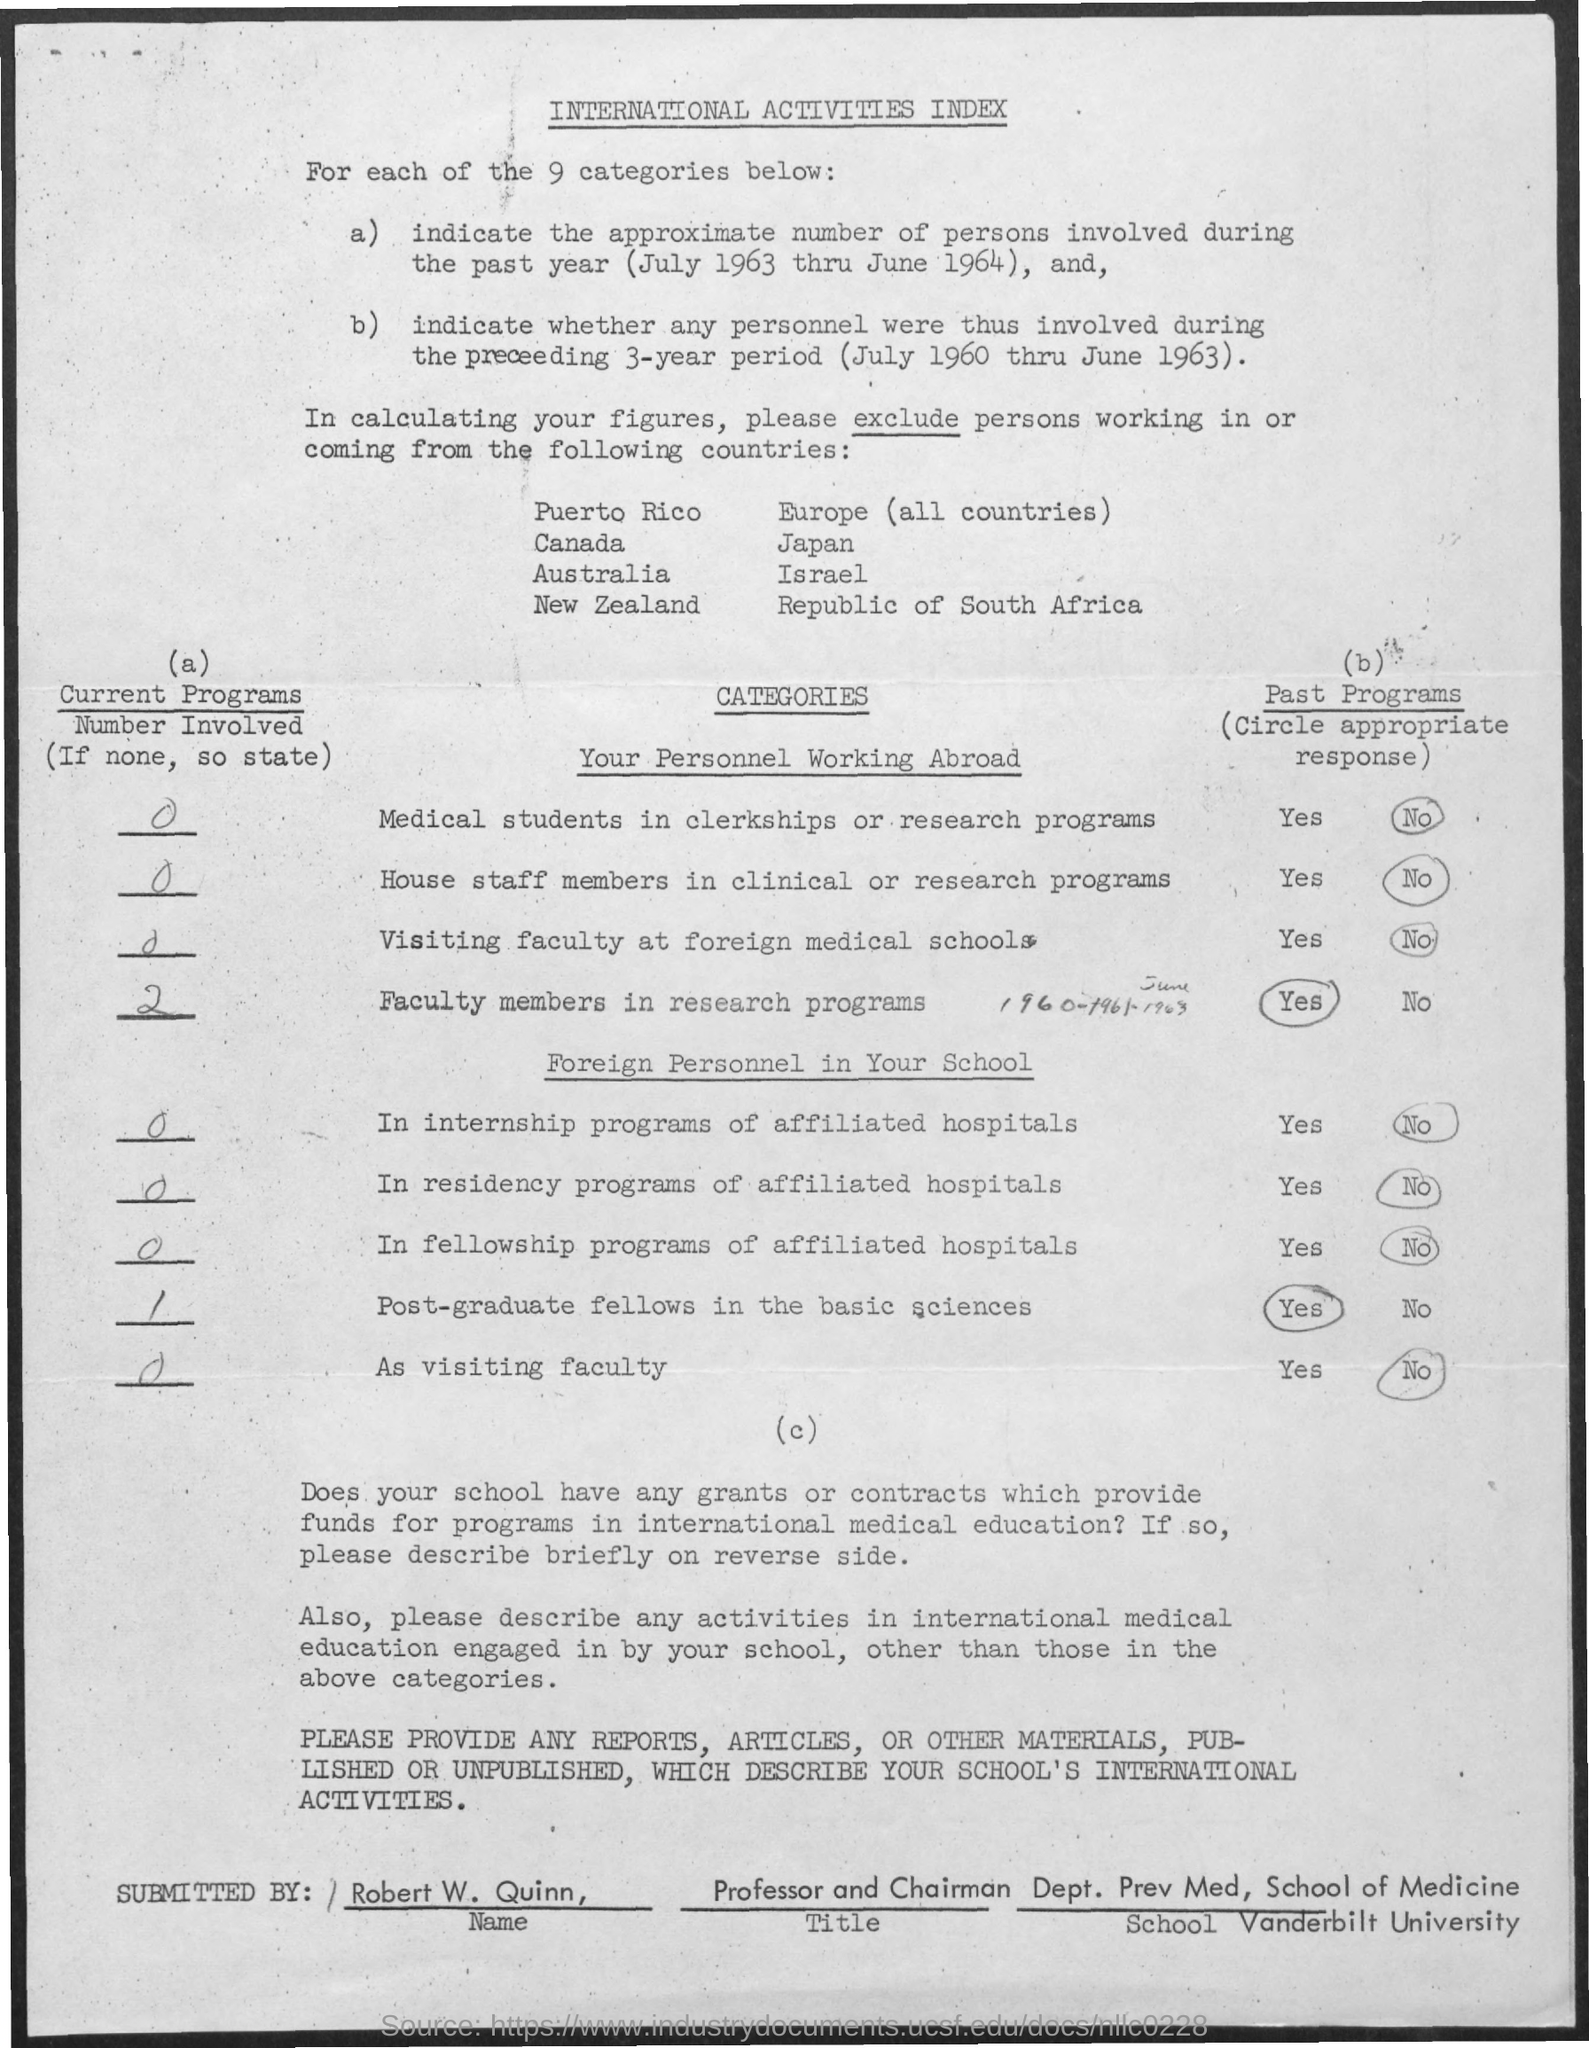What is the title of the document?
Keep it short and to the point. International Activities Index. How many categories are there?
Offer a very short reply. 9 categories. What is the designation of Robert W. Quinn?
Offer a very short reply. Professor and chairman. Robert W. Quinn belongs to which university?
Keep it short and to the point. Vanderbilt university. 